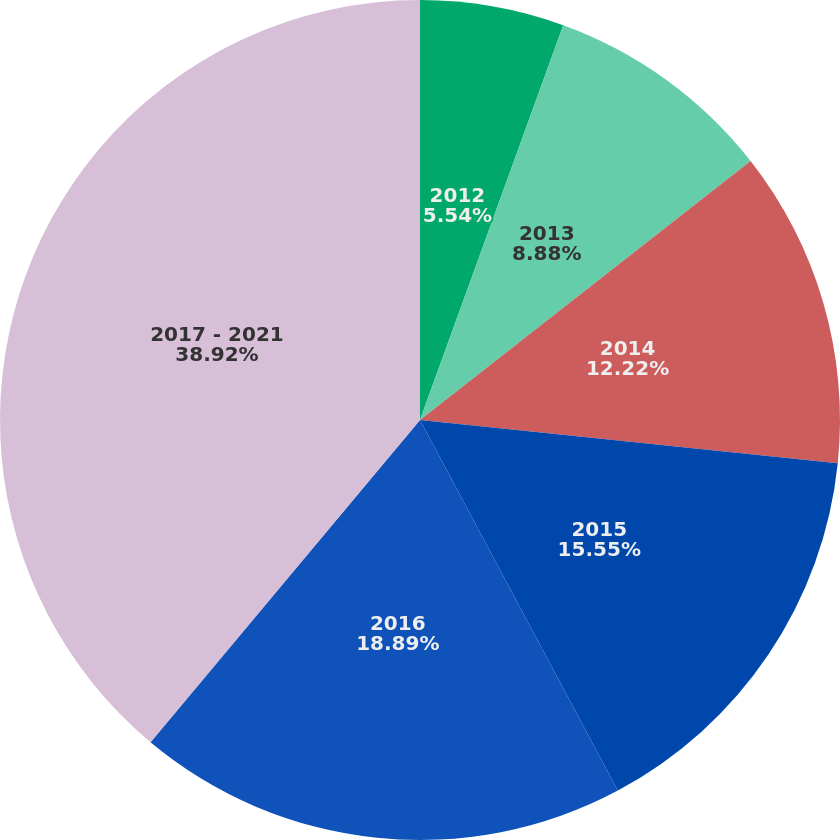Convert chart. <chart><loc_0><loc_0><loc_500><loc_500><pie_chart><fcel>2012<fcel>2013<fcel>2014<fcel>2015<fcel>2016<fcel>2017 - 2021<nl><fcel>5.54%<fcel>8.88%<fcel>12.22%<fcel>15.55%<fcel>18.89%<fcel>38.91%<nl></chart> 